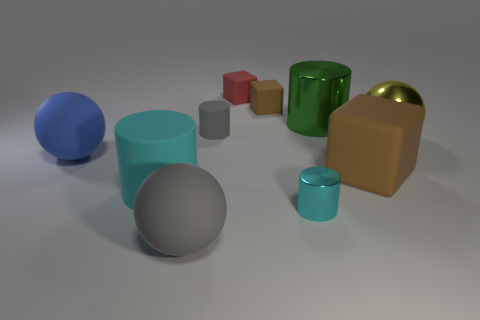What is the size of the matte object that is the same color as the small metal cylinder?
Your response must be concise. Large. The thing that is the same color as the large matte block is what shape?
Give a very brief answer. Cube. Are there fewer big yellow things to the left of the red rubber block than tiny metallic cylinders that are behind the large yellow ball?
Offer a very short reply. No. There is a large rubber object that is right of the sphere that is in front of the cyan metal cylinder; what is its shape?
Provide a succinct answer. Cube. Is there anything else that has the same color as the big rubber block?
Provide a succinct answer. Yes. Is the color of the tiny shiny thing the same as the large matte cube?
Ensure brevity in your answer.  No. What number of red objects are either tiny matte cylinders or metallic objects?
Keep it short and to the point. 0. Are there fewer large metallic cylinders on the left side of the tiny brown cube than big purple metallic spheres?
Give a very brief answer. No. How many big blue objects are to the left of the sphere right of the large brown cube?
Ensure brevity in your answer.  1. How many other objects are the same size as the yellow ball?
Make the answer very short. 5. 